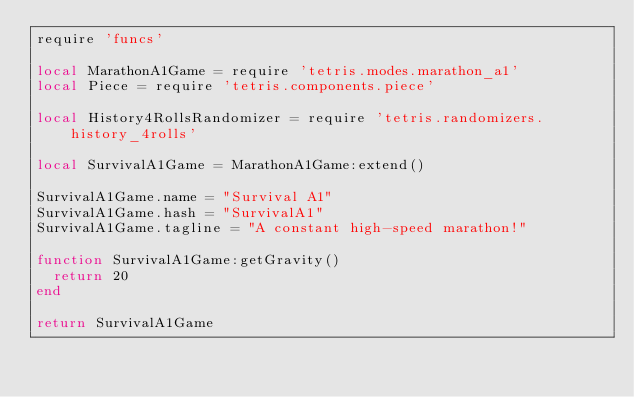<code> <loc_0><loc_0><loc_500><loc_500><_Lua_>require 'funcs'

local MarathonA1Game = require 'tetris.modes.marathon_a1'
local Piece = require 'tetris.components.piece'

local History4RollsRandomizer = require 'tetris.randomizers.history_4rolls'

local SurvivalA1Game = MarathonA1Game:extend()

SurvivalA1Game.name = "Survival A1"
SurvivalA1Game.hash = "SurvivalA1"
SurvivalA1Game.tagline = "A constant high-speed marathon!"

function SurvivalA1Game:getGravity()
	return 20
end

return SurvivalA1Game
</code> 